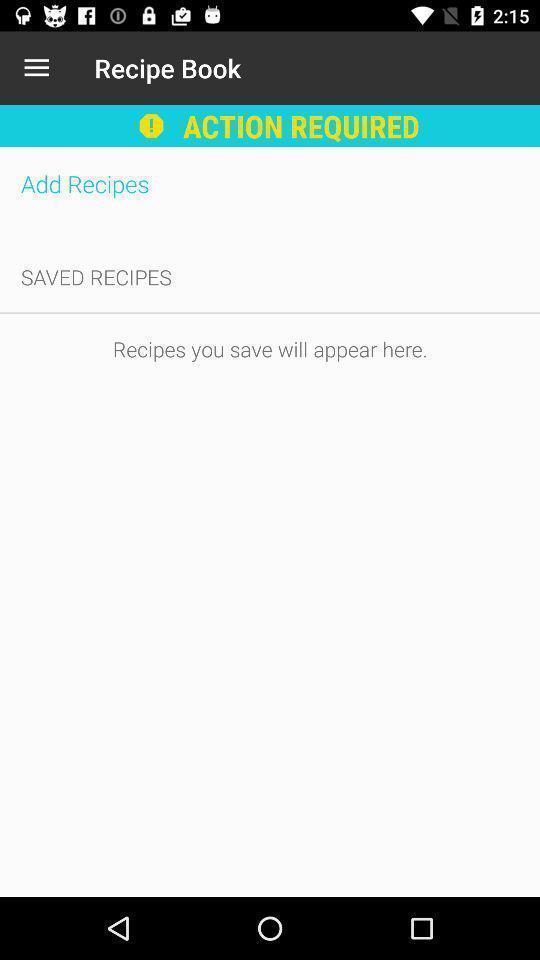Provide a textual representation of this image. Page to add recipes. 